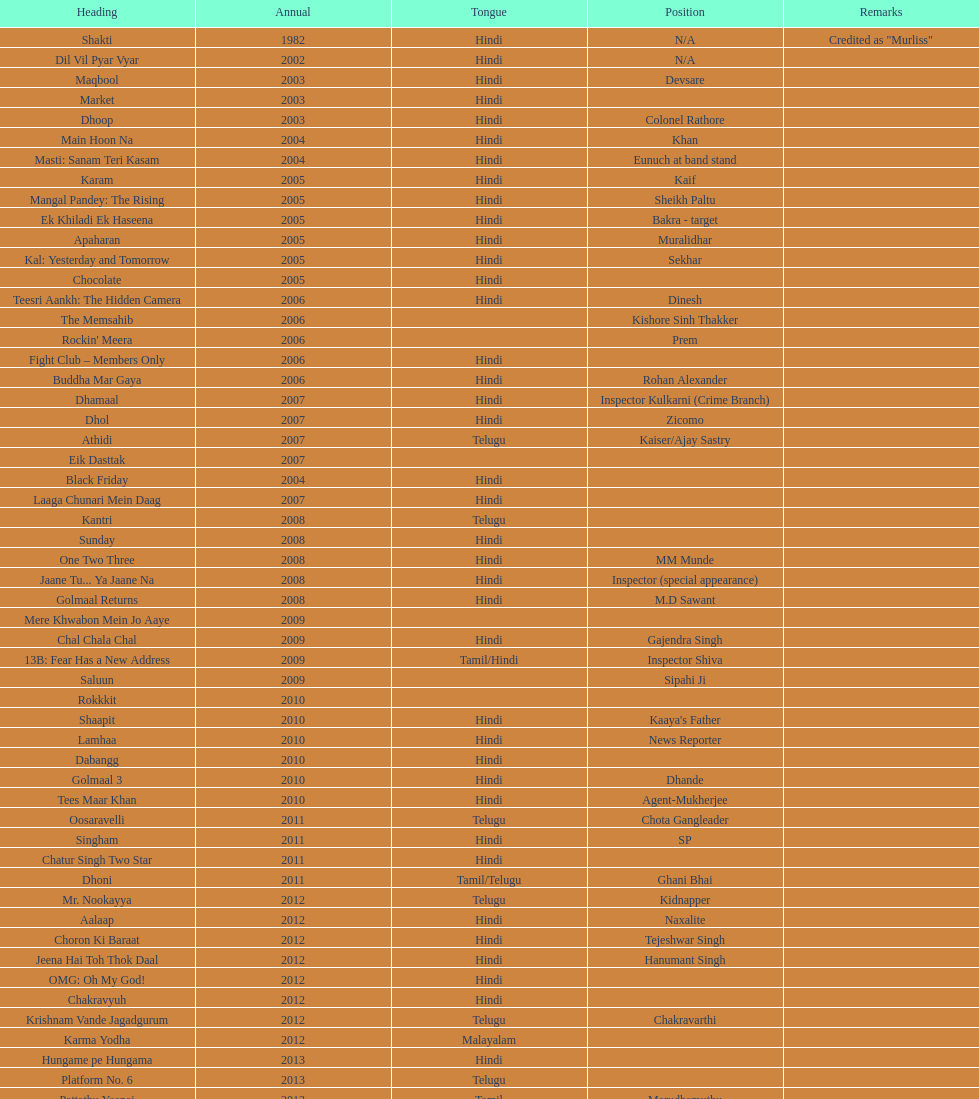What was the last malayalam film this actor starred in? Karma Yodha. 